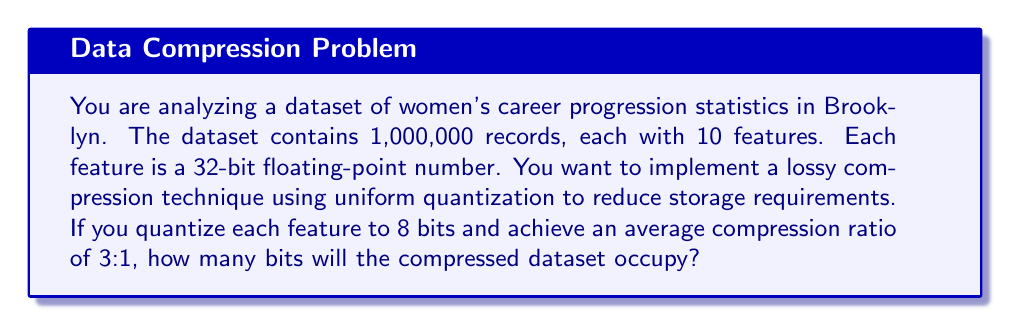Could you help me with this problem? Let's approach this step-by-step:

1) First, calculate the original size of the dataset:
   - Number of records: 1,000,000
   - Number of features per record: 10
   - Bits per feature: 32 (32-bit floating-point)
   
   Original size = $1,000,000 \times 10 \times 32 = 320,000,000$ bits

2) After quantization, each feature will occupy 8 bits instead of 32:
   Quantized size = $1,000,000 \times 10 \times 8 = 80,000,000$ bits

3) However, the question states that an average compression ratio of 3:1 is achieved. This means that the final compressed size will be 1/3 of the quantized size:

   $$\text{Compressed size} = \frac{\text{Quantized size}}{3} = \frac{80,000,000}{3} \approx 26,666,667 \text{ bits}$$

4) Since we can't have a fractional bit, we round up to the nearest whole number:
   Compressed size = 26,666,667 bits

This compression technique significantly reduces the storage requirement from 320,000,000 bits to 26,666,667 bits, which is particularly useful for storing and analyzing large datasets of career progression statistics.
Answer: 26,666,667 bits 